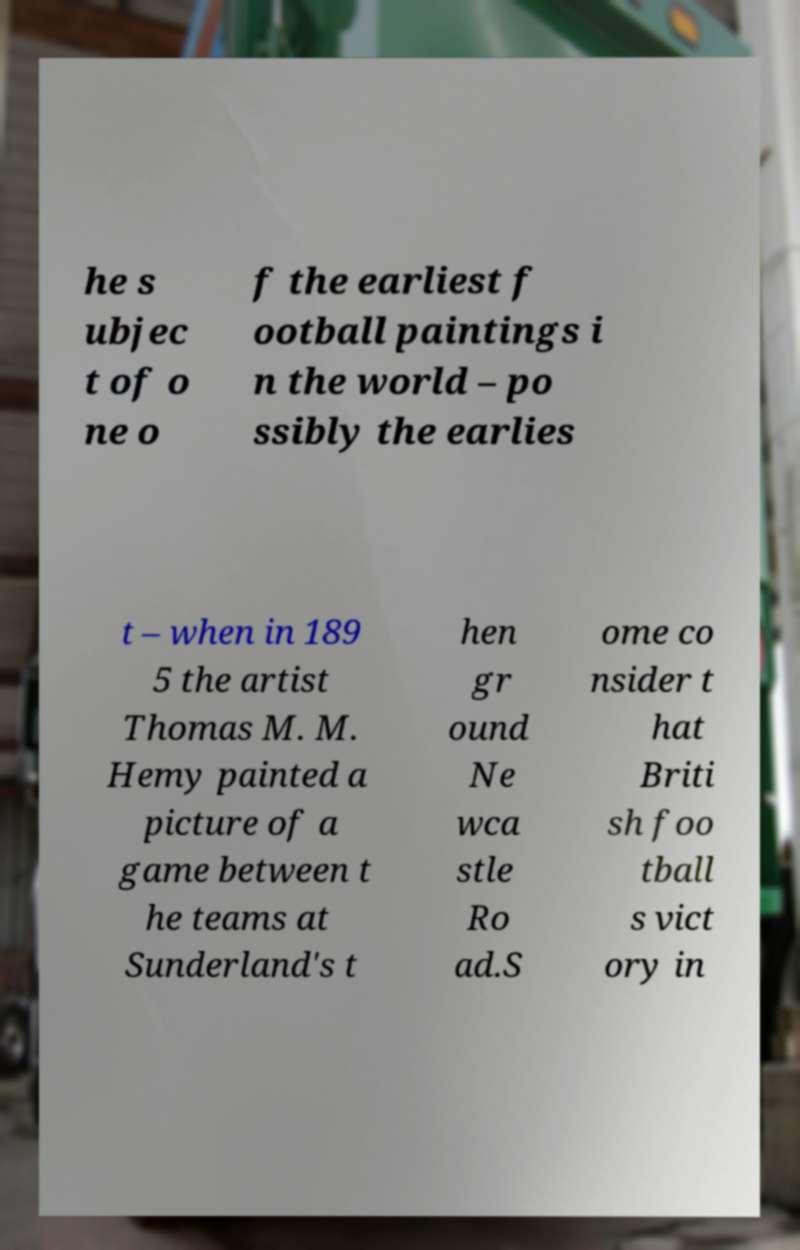Please identify and transcribe the text found in this image. he s ubjec t of o ne o f the earliest f ootball paintings i n the world – po ssibly the earlies t – when in 189 5 the artist Thomas M. M. Hemy painted a picture of a game between t he teams at Sunderland's t hen gr ound Ne wca stle Ro ad.S ome co nsider t hat Briti sh foo tball s vict ory in 